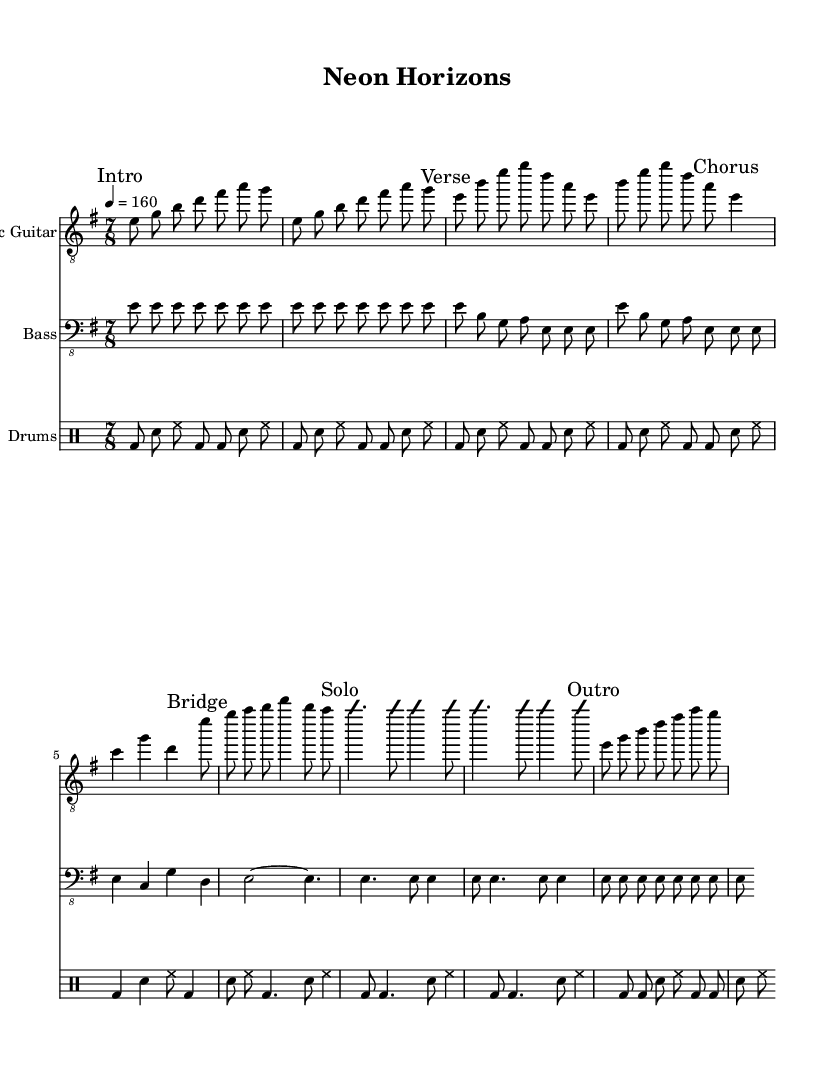What is the key signature of this music? The key signature is E minor, which has one sharp (F#). This can be identified from the global section where " \key e \minor" indicates the key.
Answer: E minor What is the time signature of this music? The time signature is 7/8, as indicated in the global section with "\time 7/8". This means there are seven eighth notes in each measure.
Answer: 7/8 What is the tempo marking indicated in the music? The tempo is 160 beats per minute, shown as "4 = 160" in the global section. This means there are four quarter notes per minute setting a fast pace.
Answer: 160 How many measures are present in the chorus section? The chorus section consists of 3 measures: e4 c g' d. By counting the notes indicated in the chorus section, we can see there are three distinct groupings.
Answer: 3 What type of improvisation is indicated in the solo section? The solo section specifies 'improvisation on', which means the performer has creative freedom during this part. This is a characteristic of many metal solos, encouraging personal expression.
Answer: improvisation on What is the instrument for which the music is primarily composed? The music is primarily composed for the electric guitar, as indicated at the top of the respective staff in the score. It is a staple instrument in metal music, associated with distinctive riffs and solos.
Answer: Electric Guitar What rhythmic pattern is repeated in the drum section? The drum section repeats a pattern with bass drum, snare, and hi-hat, shown as "bd8 sn hh" throughout the piece. This pattern is common in many metal songs emphasizing the backbeat and driving rhythm.
Answer: bd8 sn hh 